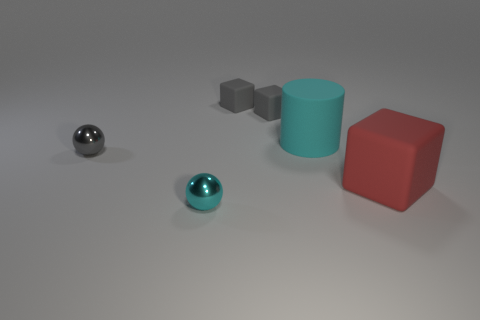Subtract all yellow cylinders. Subtract all red blocks. How many cylinders are left? 1 Add 1 cylinders. How many objects exist? 7 Subtract all cylinders. How many objects are left? 5 Subtract all tiny cyan shiny objects. Subtract all big cyan rubber cylinders. How many objects are left? 4 Add 3 tiny gray rubber cubes. How many tiny gray rubber cubes are left? 5 Add 1 cyan cylinders. How many cyan cylinders exist? 2 Subtract 2 gray cubes. How many objects are left? 4 